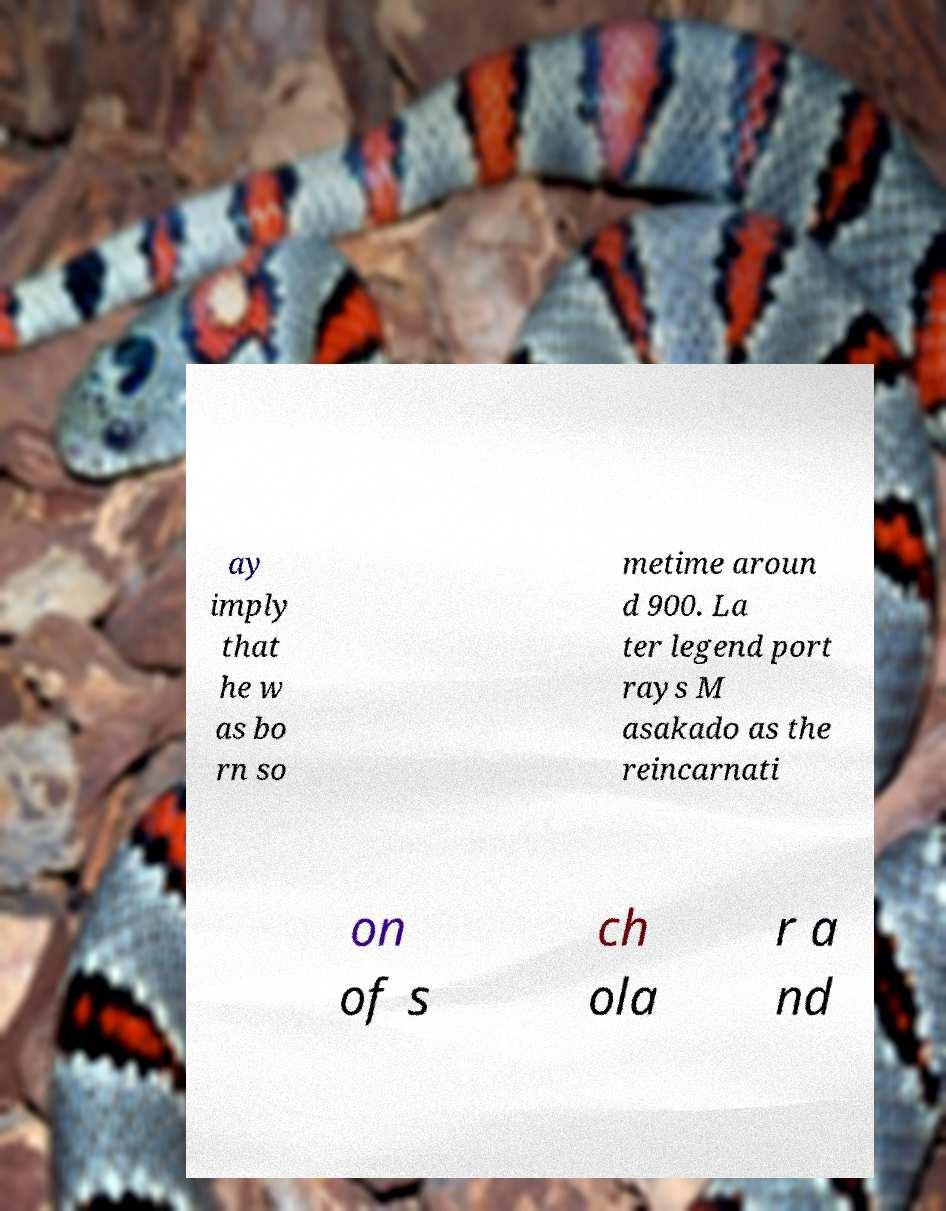Can you accurately transcribe the text from the provided image for me? ay imply that he w as bo rn so metime aroun d 900. La ter legend port rays M asakado as the reincarnati on of s ch ola r a nd 